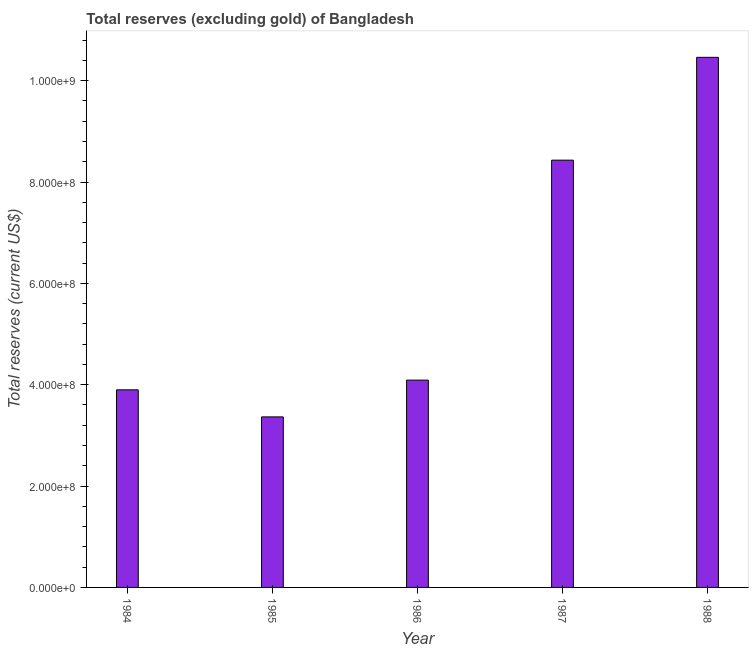What is the title of the graph?
Your response must be concise. Total reserves (excluding gold) of Bangladesh. What is the label or title of the Y-axis?
Provide a short and direct response. Total reserves (current US$). What is the total reserves (excluding gold) in 1985?
Make the answer very short. 3.37e+08. Across all years, what is the maximum total reserves (excluding gold)?
Make the answer very short. 1.05e+09. Across all years, what is the minimum total reserves (excluding gold)?
Give a very brief answer. 3.37e+08. What is the sum of the total reserves (excluding gold)?
Make the answer very short. 3.02e+09. What is the difference between the total reserves (excluding gold) in 1986 and 1988?
Your answer should be very brief. -6.37e+08. What is the average total reserves (excluding gold) per year?
Provide a succinct answer. 6.05e+08. What is the median total reserves (excluding gold)?
Your answer should be compact. 4.09e+08. In how many years, is the total reserves (excluding gold) greater than 360000000 US$?
Your answer should be very brief. 4. What is the ratio of the total reserves (excluding gold) in 1985 to that in 1987?
Your answer should be compact. 0.4. Is the total reserves (excluding gold) in 1984 less than that in 1988?
Your answer should be compact. Yes. What is the difference between the highest and the second highest total reserves (excluding gold)?
Make the answer very short. 2.03e+08. Is the sum of the total reserves (excluding gold) in 1984 and 1987 greater than the maximum total reserves (excluding gold) across all years?
Provide a succinct answer. Yes. What is the difference between the highest and the lowest total reserves (excluding gold)?
Give a very brief answer. 7.10e+08. How many bars are there?
Offer a very short reply. 5. How many years are there in the graph?
Your answer should be compact. 5. What is the difference between two consecutive major ticks on the Y-axis?
Ensure brevity in your answer.  2.00e+08. Are the values on the major ticks of Y-axis written in scientific E-notation?
Make the answer very short. Yes. What is the Total reserves (current US$) in 1984?
Keep it short and to the point. 3.90e+08. What is the Total reserves (current US$) in 1985?
Your answer should be very brief. 3.37e+08. What is the Total reserves (current US$) of 1986?
Your response must be concise. 4.09e+08. What is the Total reserves (current US$) of 1987?
Ensure brevity in your answer.  8.43e+08. What is the Total reserves (current US$) of 1988?
Ensure brevity in your answer.  1.05e+09. What is the difference between the Total reserves (current US$) in 1984 and 1985?
Offer a terse response. 5.34e+07. What is the difference between the Total reserves (current US$) in 1984 and 1986?
Your response must be concise. -1.92e+07. What is the difference between the Total reserves (current US$) in 1984 and 1987?
Provide a succinct answer. -4.53e+08. What is the difference between the Total reserves (current US$) in 1984 and 1988?
Give a very brief answer. -6.56e+08. What is the difference between the Total reserves (current US$) in 1985 and 1986?
Offer a terse response. -7.26e+07. What is the difference between the Total reserves (current US$) in 1985 and 1987?
Offer a very short reply. -5.07e+08. What is the difference between the Total reserves (current US$) in 1985 and 1988?
Keep it short and to the point. -7.10e+08. What is the difference between the Total reserves (current US$) in 1986 and 1987?
Your answer should be very brief. -4.34e+08. What is the difference between the Total reserves (current US$) in 1986 and 1988?
Ensure brevity in your answer.  -6.37e+08. What is the difference between the Total reserves (current US$) in 1987 and 1988?
Provide a short and direct response. -2.03e+08. What is the ratio of the Total reserves (current US$) in 1984 to that in 1985?
Provide a succinct answer. 1.16. What is the ratio of the Total reserves (current US$) in 1984 to that in 1986?
Your response must be concise. 0.95. What is the ratio of the Total reserves (current US$) in 1984 to that in 1987?
Make the answer very short. 0.46. What is the ratio of the Total reserves (current US$) in 1984 to that in 1988?
Provide a short and direct response. 0.37. What is the ratio of the Total reserves (current US$) in 1985 to that in 1986?
Keep it short and to the point. 0.82. What is the ratio of the Total reserves (current US$) in 1985 to that in 1987?
Give a very brief answer. 0.4. What is the ratio of the Total reserves (current US$) in 1985 to that in 1988?
Make the answer very short. 0.32. What is the ratio of the Total reserves (current US$) in 1986 to that in 1987?
Your response must be concise. 0.48. What is the ratio of the Total reserves (current US$) in 1986 to that in 1988?
Ensure brevity in your answer.  0.39. What is the ratio of the Total reserves (current US$) in 1987 to that in 1988?
Provide a succinct answer. 0.81. 